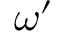<formula> <loc_0><loc_0><loc_500><loc_500>\omega ^ { \prime }</formula> 